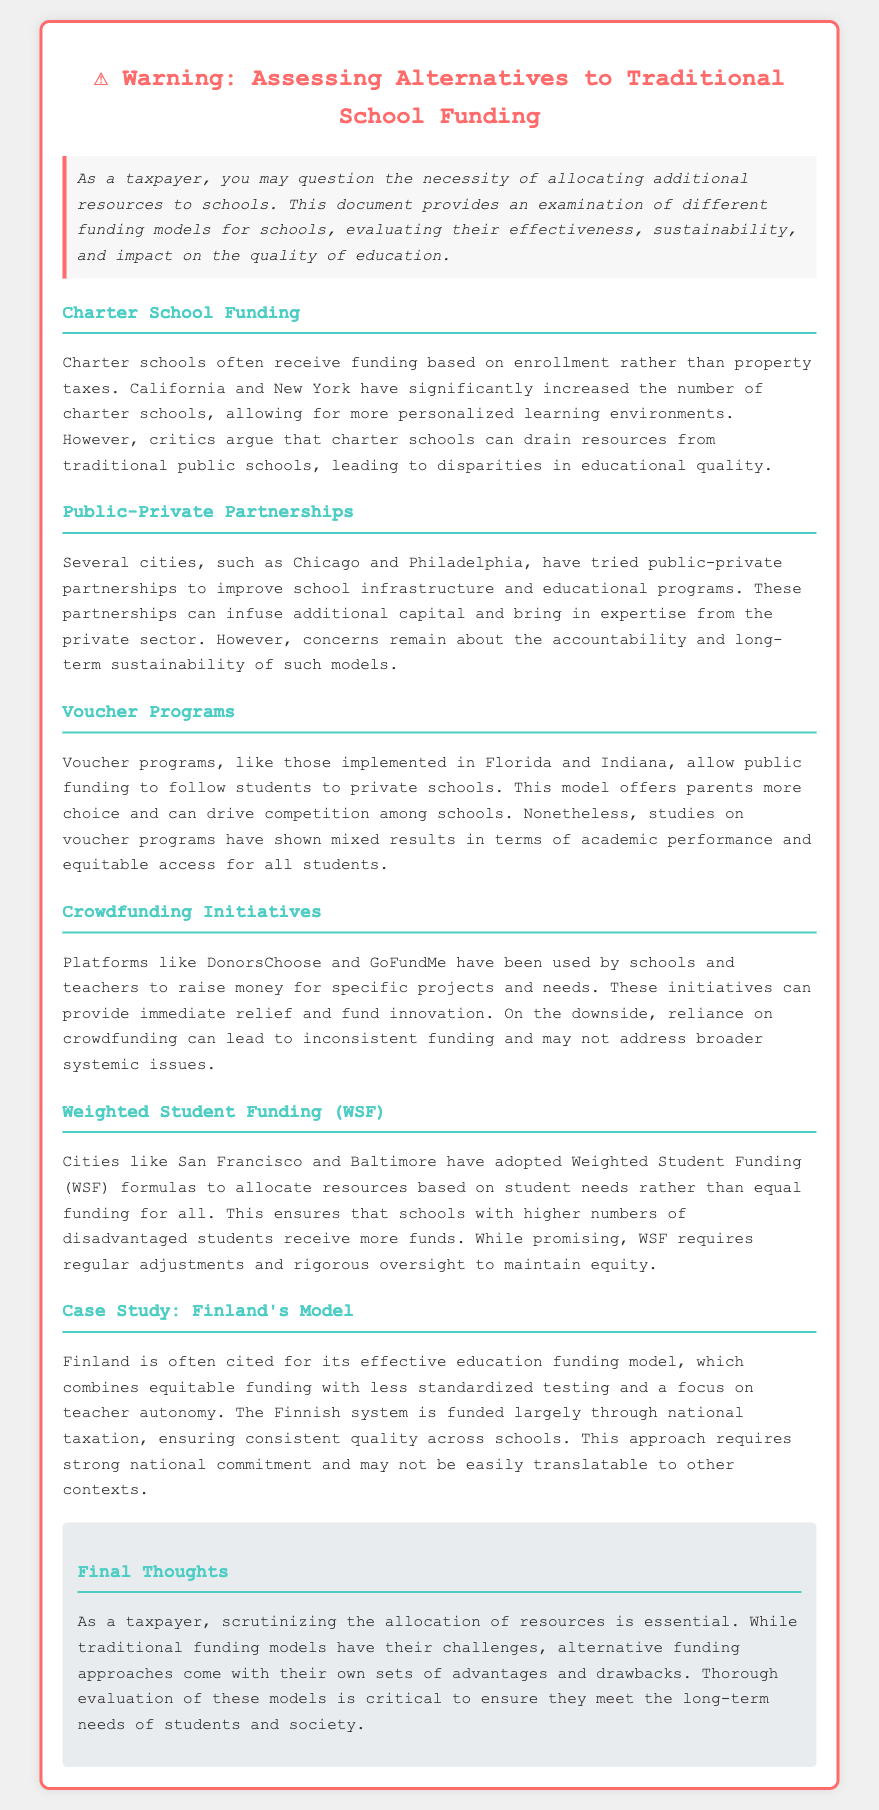What is the title of the document? The title is prominently displayed at the top of the document.
Answer: ⚠️ Warning: Assessing Alternatives to Traditional School Funding Which funding model allows public funding to follow students to private schools? This model is described in the section discussing voucher programs.
Answer: Voucher programs What city is mentioned as having experimented with public-private partnerships? The document mentions specific cities that have tried this approach.
Answer: Chicago What funding model is adopted by cities like San Francisco and Baltimore? This information is found in the section about resource allocation based on student needs.
Answer: Weighted Student Funding (WSF) What country is cited for its effective education funding model? The document discusses this country's education model as a case study.
Answer: Finland What concern is associated with crowdfunding initiatives? The document includes a downside of relying on these funding methods.
Answer: Inconsistent funding How are charter schools primarily funded? This is specified in the section on charter school funding.
Answer: Based on enrollment What must Weighted Student Funding (WSF) require regularly? This requirement is highlighted in the section discussing this funding model.
Answer: Regular adjustments 